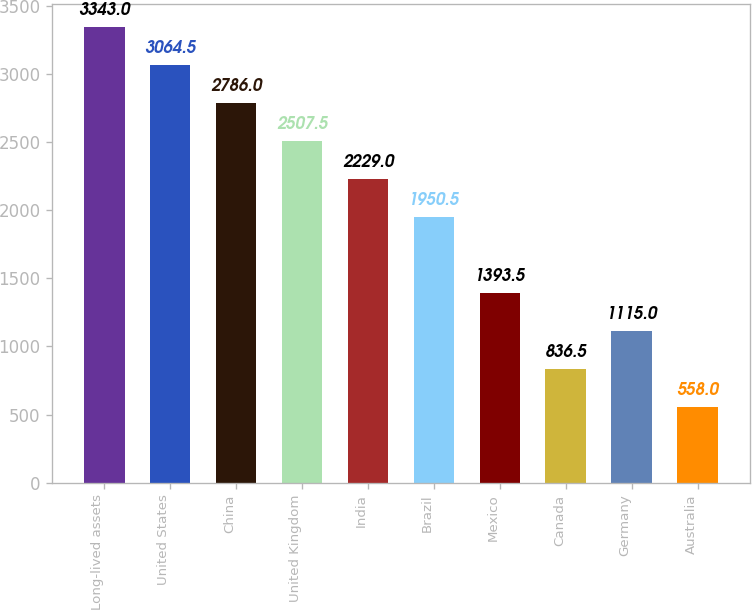Convert chart. <chart><loc_0><loc_0><loc_500><loc_500><bar_chart><fcel>Long-lived assets<fcel>United States<fcel>China<fcel>United Kingdom<fcel>India<fcel>Brazil<fcel>Mexico<fcel>Canada<fcel>Germany<fcel>Australia<nl><fcel>3343<fcel>3064.5<fcel>2786<fcel>2507.5<fcel>2229<fcel>1950.5<fcel>1393.5<fcel>836.5<fcel>1115<fcel>558<nl></chart> 